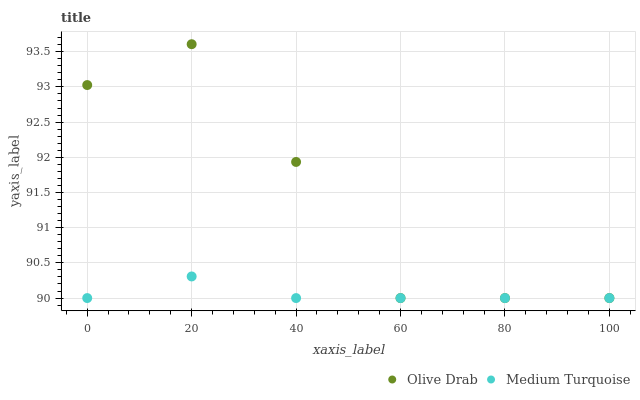Does Medium Turquoise have the minimum area under the curve?
Answer yes or no. Yes. Does Olive Drab have the maximum area under the curve?
Answer yes or no. Yes. Does Olive Drab have the minimum area under the curve?
Answer yes or no. No. Is Medium Turquoise the smoothest?
Answer yes or no. Yes. Is Olive Drab the roughest?
Answer yes or no. Yes. Is Olive Drab the smoothest?
Answer yes or no. No. Does Medium Turquoise have the lowest value?
Answer yes or no. Yes. Does Olive Drab have the highest value?
Answer yes or no. Yes. Does Medium Turquoise intersect Olive Drab?
Answer yes or no. Yes. Is Medium Turquoise less than Olive Drab?
Answer yes or no. No. Is Medium Turquoise greater than Olive Drab?
Answer yes or no. No. 